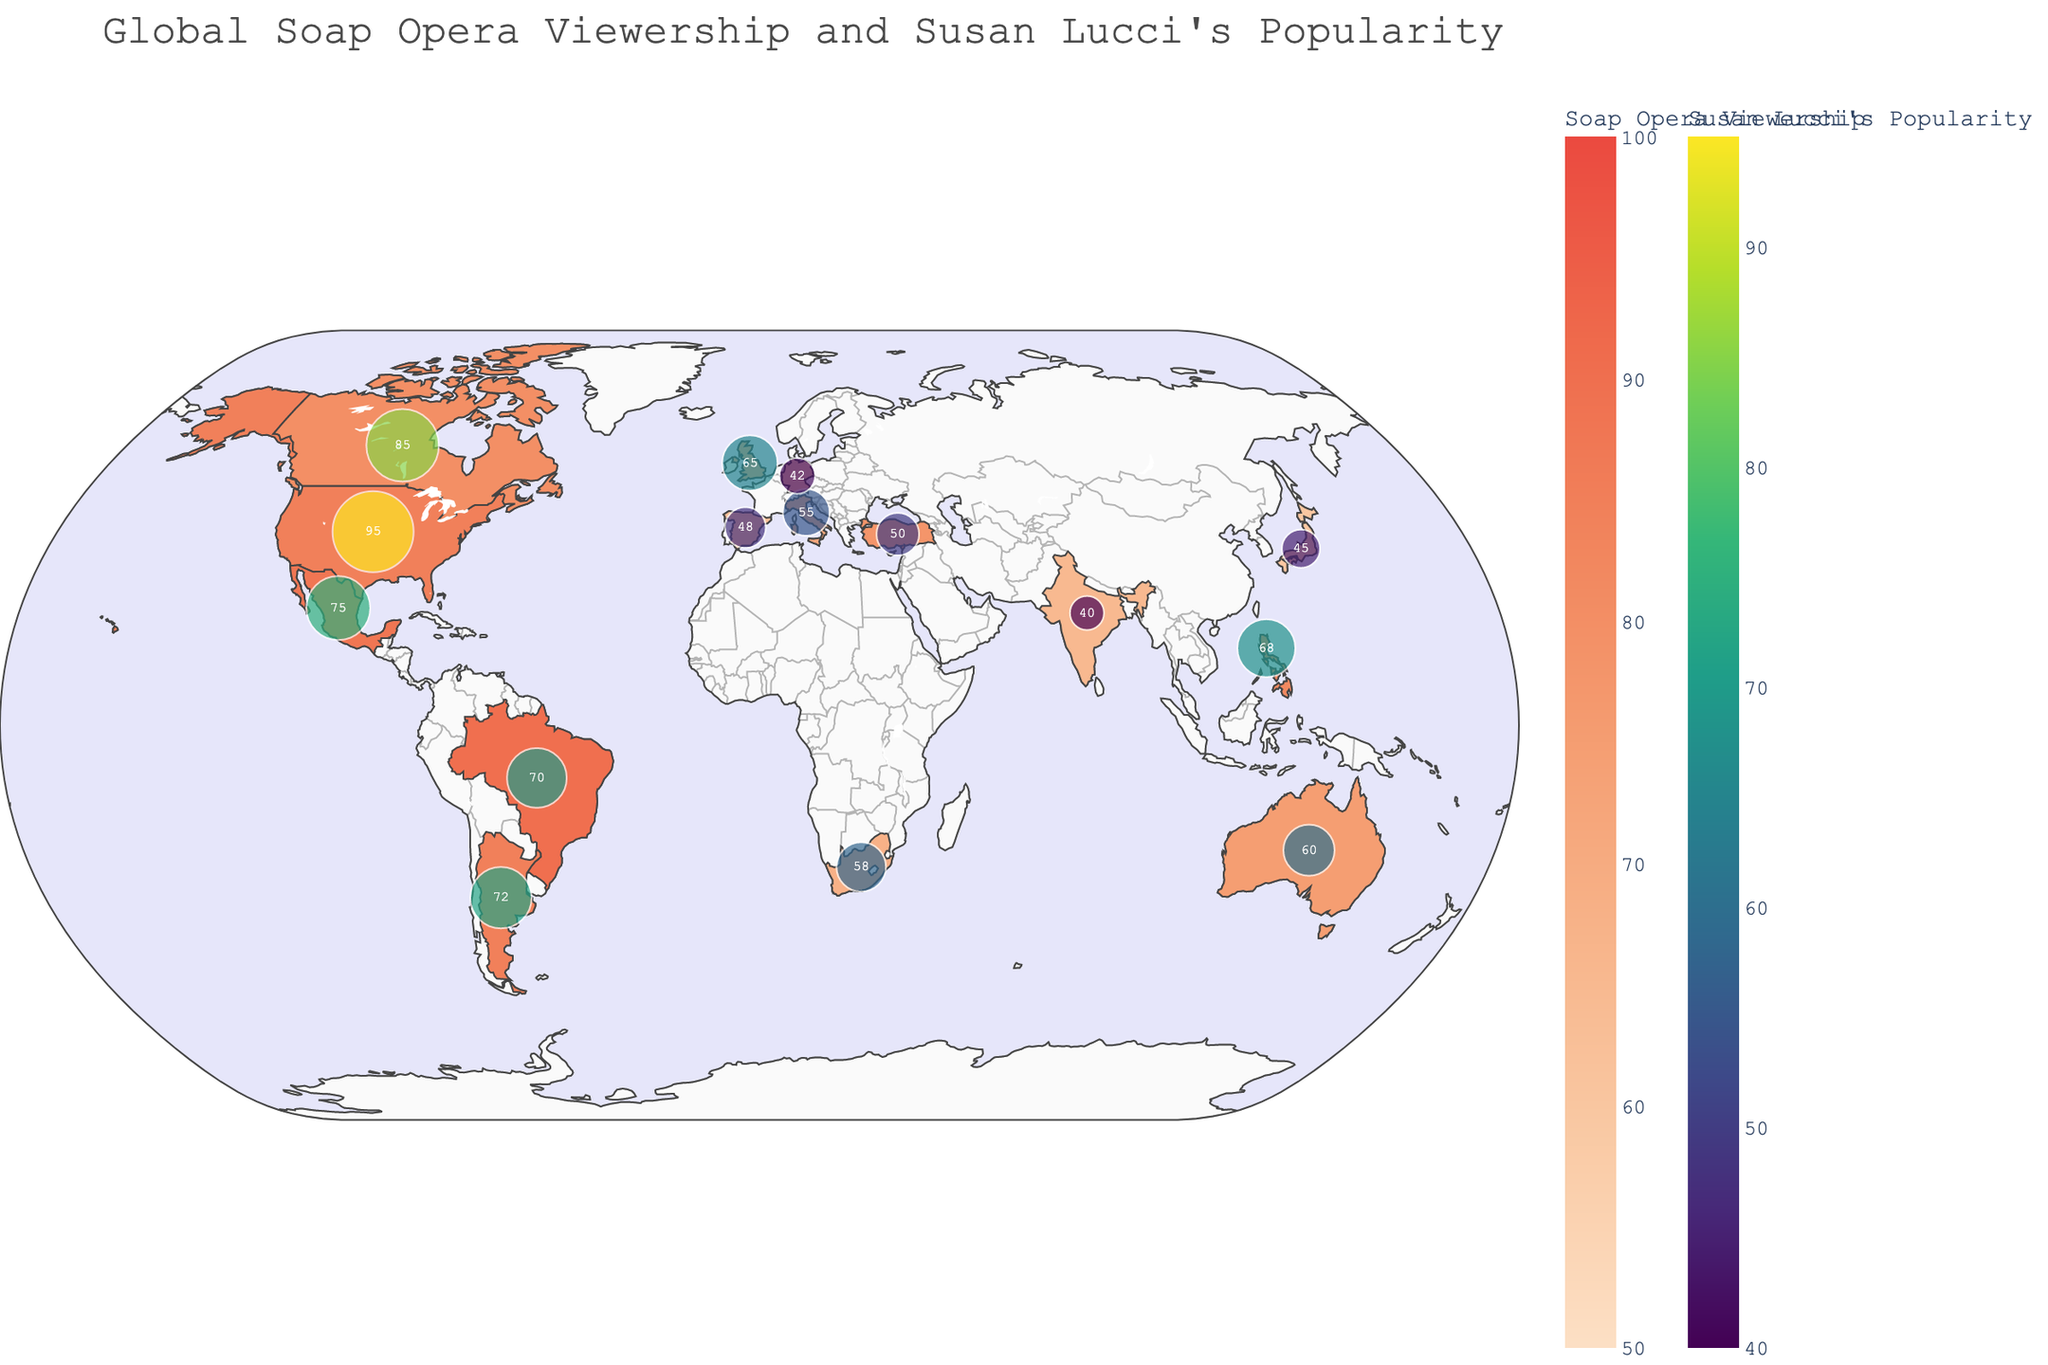what is the title of the plot? The title of the plot is typically positioned at the top center of the figure. From visual observation, it clearly states the main focus of the figure.
Answer: Global Soap Opera Viewership and Susan Lucci's Popularity Which country has the highest soap opera viewership? Look for the country with the darkest color in the choropleth map. The hover information or the legend can also help identify the specific value.
Answer: Brazil How is Susan Lucci’s popularity indicated on the map? Susan Lucci’s popularity is shown using markers positioned on each country. The size and color of the markers correlate with the popularity value labeled next to the markers.
Answer: Markers with size and color scaling Compare Susan Lucci's popularity in the United States and Canada. Which country shows a higher popularity? The markers for Susan Lucci’s popularity display numerical values. Comparing these values directly from the figure, you determine which is higher.
Answer: United States What is the range of soap opera viewership values shown on the map? The color bar or legend for soap opera viewership should indicate the range with its endpoints.
Answer: 50 to 100 In how many countries is Susan Lucci’s popularity greater than 60? Identify and count the markers that have numerical values greater than 60.
Answer: 8 countries Which country has the lowest Susan Lucci popularity? Look for the marker with the smallest size and a numerical label indicating the lowest value.
Answer: India What's the average soap opera viewership in the listed countries? Add up all the soap opera viewership values and divide by the number of countries. There are 14 countries, and summing the viewership values gives (85 + 90 + 70 + 75 + 60 + 88 + 72 + 82 + 78 + 65 + 80 + 68 + 55 + 63 + 85) = 1066. Dividing by 14 gives approximately 76.
Answer: 76 Does Italy or Turkey have a higher Susan Lucci popularity? Compare the values labeled next to the markers for Italy and Turkey.
Answer: Italy Which country in Asia has the highest soap opera viewership? Locate the Asian countries listed and compare their viewership values: Japan, Philippines, and India. The highest value among these though is Philippines at 82.
Answer: Philippines What is the color scale used for Susan Lucci’s popularity on the map? The color scale for Susan Lucci’s popularity is indicated alongside the markers in the legend which can be referred to understand the gradient used.
Answer: Viridis 